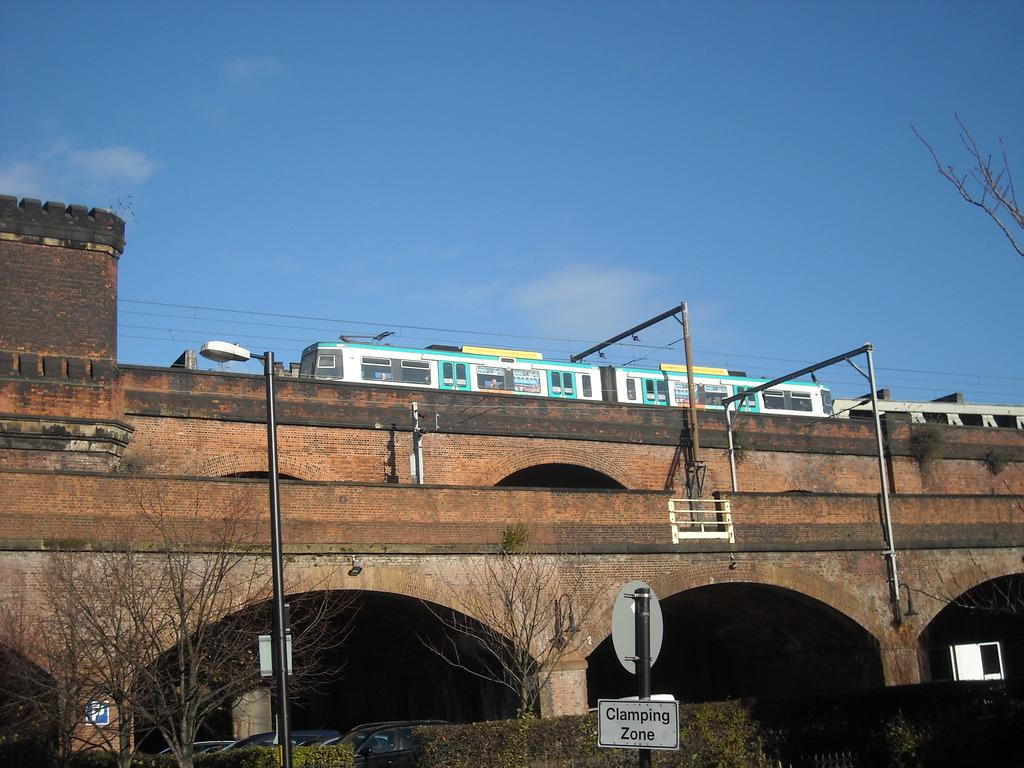What structures can be seen in the image? There are poles, boards, a light, arches, railing, a bridge, and a wall visible in the image. What type of natural elements are present in the image? There are trees, plants, and sky visible in the image. What man-made objects can be seen in the image? There are vehicles, rods, and a train visible in the image. What type of dress is being worn by the healthiest person in the image? There are no people present in the image, so it is not possible to determine the healthiest person or their attire. What religious beliefs are represented by the objects in the image? There is no information about religious beliefs in the image, as it focuses on structures and objects. 